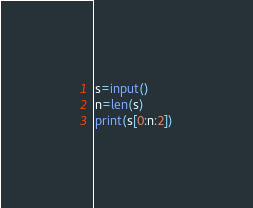Convert code to text. <code><loc_0><loc_0><loc_500><loc_500><_Python_>s=input()
n=len(s)
print(s[0:n:2])</code> 